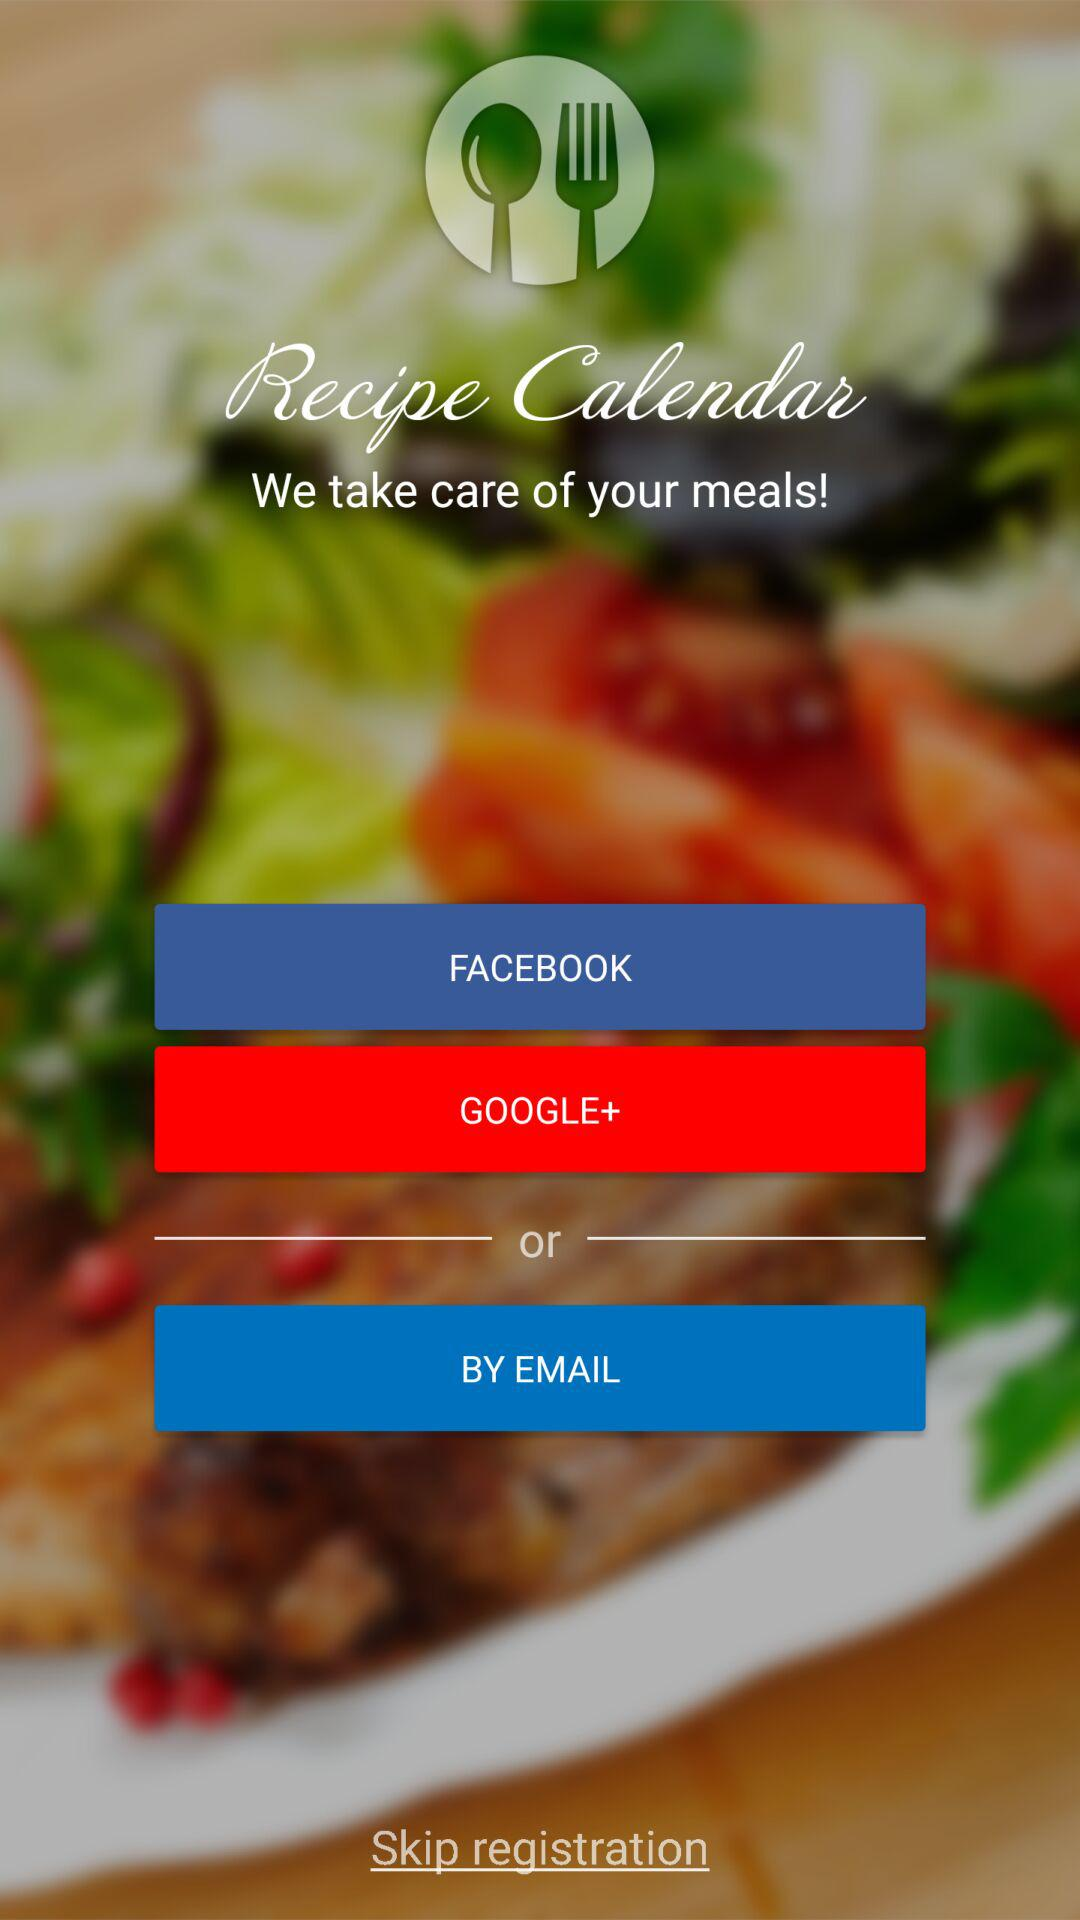What are the different options through which we can register? The different options through which we can register are "FACEBOOK", "GOOGLE+" and "EMAIL". 